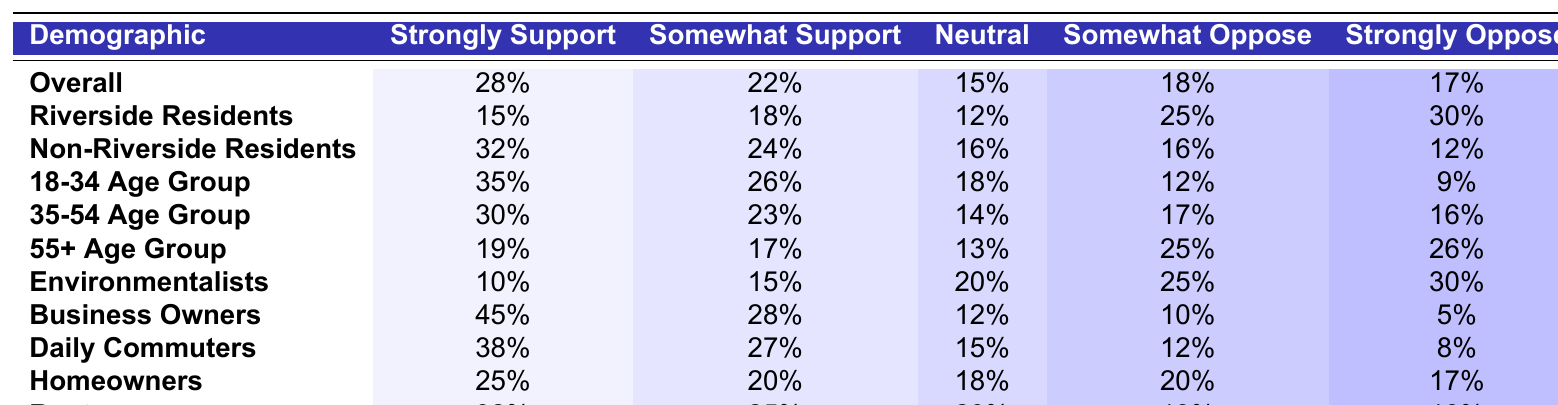What percentage of Riverside Residents strongly support the project? The table shows that 15% of Riverside Residents strongly support the project.
Answer: 15% Which demographic group shows the highest percentage of strong support for the project? Looking at the table, Business Owners have the highest percentage of strong support at 45%.
Answer: Business Owners What is the sum of the percentages for "Somewhat Support" among the 35-54 Age Group and Daily Commuters? The 35-54 Age Group has 23% and Daily Commuters have 27% for "Somewhat Support." Adding them together: 23% + 27% = 50%.
Answer: 50% Is it true that more Non-Riverside Residents oppose the project than Riverside Residents? The table indicates that 28% of Riverside Residents oppose the project (25% somewhat oppose + 30% strongly oppose) and 28% of Non-Riverside Residents oppose it (16% somewhat oppose + 12% strongly oppose). Therefore, this statement is false.
Answer: No What percentage of the 18-34 Age Group is neutral towards the project compared to the overall average? The 18-34 Age Group has 18% neutrality, and the overall average is 15%. Since 18% is greater than 15%, the 18-34 Age Group has a higher percentage of neutrality.
Answer: Yes What is the difference in the percentage of strong support between 18-34 Age Group and Environmentalists? The 18-34 Age Group has 35% strong support while Environmentalists have 10%. The difference is 35% - 10% = 25%.
Answer: 25% Which group has the lowest combined percentage of support (strongly and somewhat) for the project? Riverside Residents have the lowest combined support: 15% (strongly) + 18% (somewhat) = 33%. Other groups have higher combined percentages.
Answer: Riverside Residents What is the average percentage of "Strongly Support" across all age groups? The percentages for the age groups are 35%, 30%, and 19%. The sum is 35 + 30 + 19 = 84%, and in total, there are 3 groups. Therefore, 84% / 3 = 28%.
Answer: 28% How do homeowners' opinions compare to renters' with regard to "Somewhat Oppose"? Homeowners have 20% "Somewhat Oppose," while Renters have 13%. Homeowners show a higher percentage of opposition in this category.
Answer: Homeowners have a higher percentage 